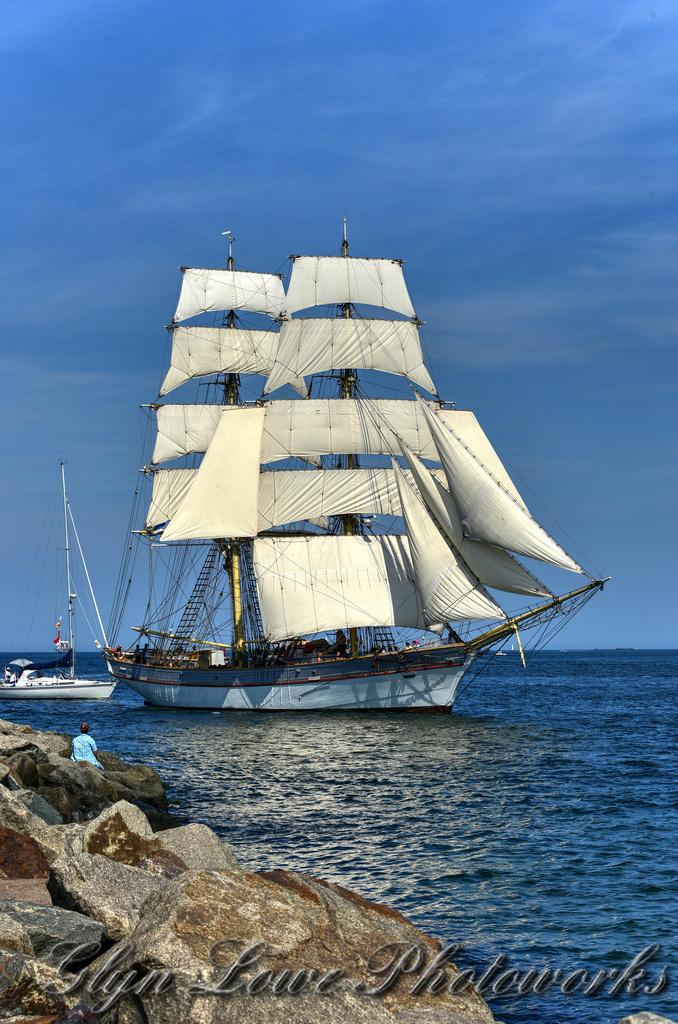What is in the water in the image? There are boats in the water. Where is the person located in the image? The person is sitting on rocks. What can be seen in the background of the image? The sky is visible in the background. What is the condition of the sky in the image? Clouds are present in the sky. What type of powder can be seen covering the boats in the image? There is no powder present in the image; the boats are in the water. How is the string used by the person sitting on rocks in the image? There is no string present in the image; the person is sitting on rocks without any visible string. 